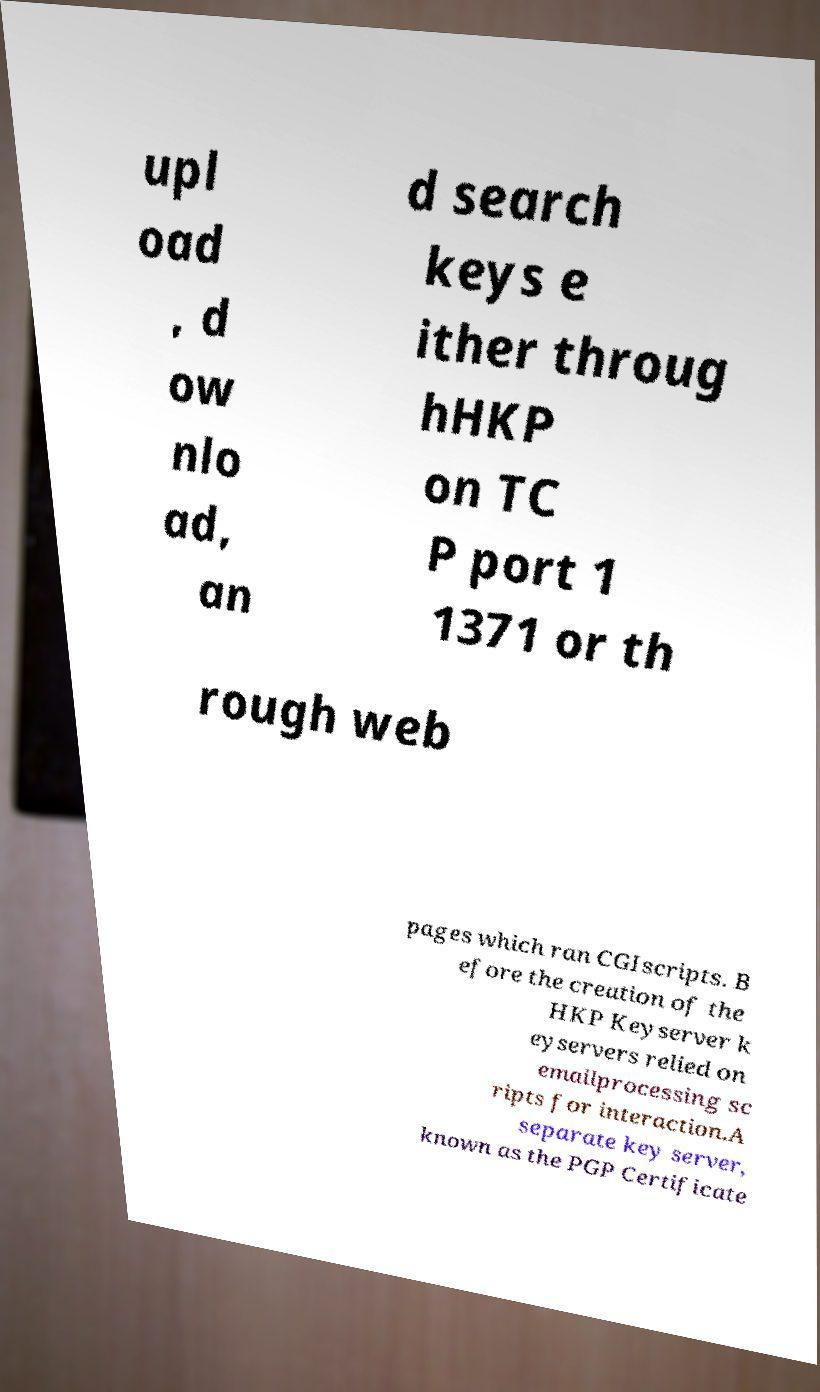For documentation purposes, I need the text within this image transcribed. Could you provide that? upl oad , d ow nlo ad, an d search keys e ither throug hHKP on TC P port 1 1371 or th rough web pages which ran CGIscripts. B efore the creation of the HKP Keyserver k eyservers relied on emailprocessing sc ripts for interaction.A separate key server, known as the PGP Certificate 